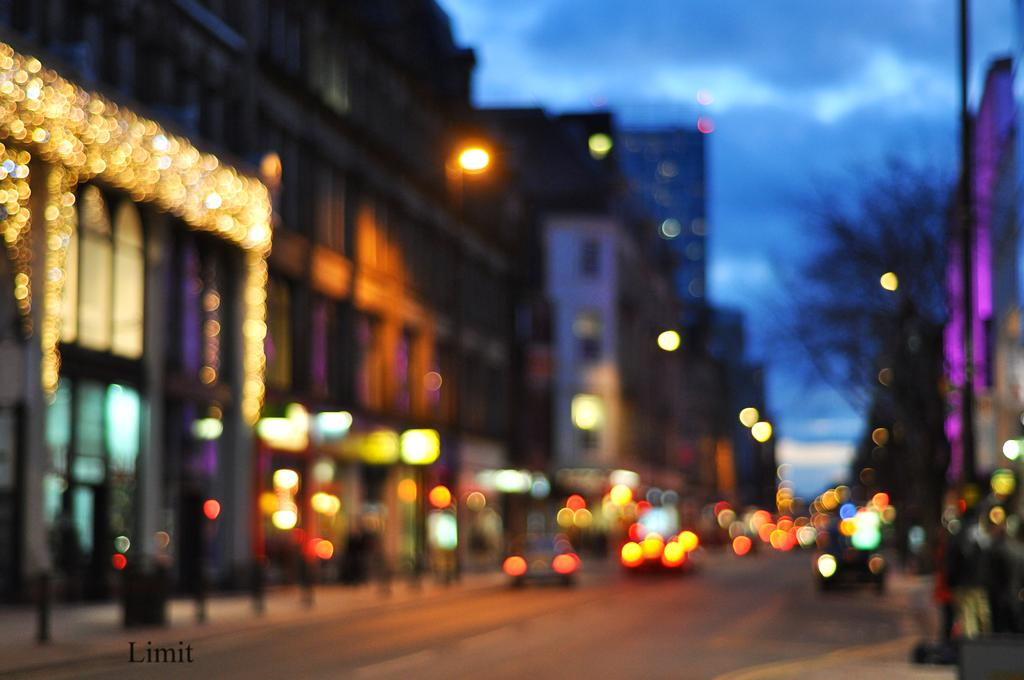What type of structures can be seen in the image? There are many buildings in the image. What else is visible besides the buildings? There are vehicles, lights, a road, a tree, and a cloudy sky in the image. Can you describe the road in the image? The road is visible in the image. What is the condition of the sky in the image? The sky is cloudy in the image. Is there any indication of the image quality? Yes, the image is blurred. Is there any additional marking on the image? Yes, there is a watermark in the image. Can you tell me how many shoes are visible in the image? There are no shoes present in the image. What type of lead can be seen connecting the buildings in the image? There is no lead connecting the buildings in the image; it is a collection of separate structures. 